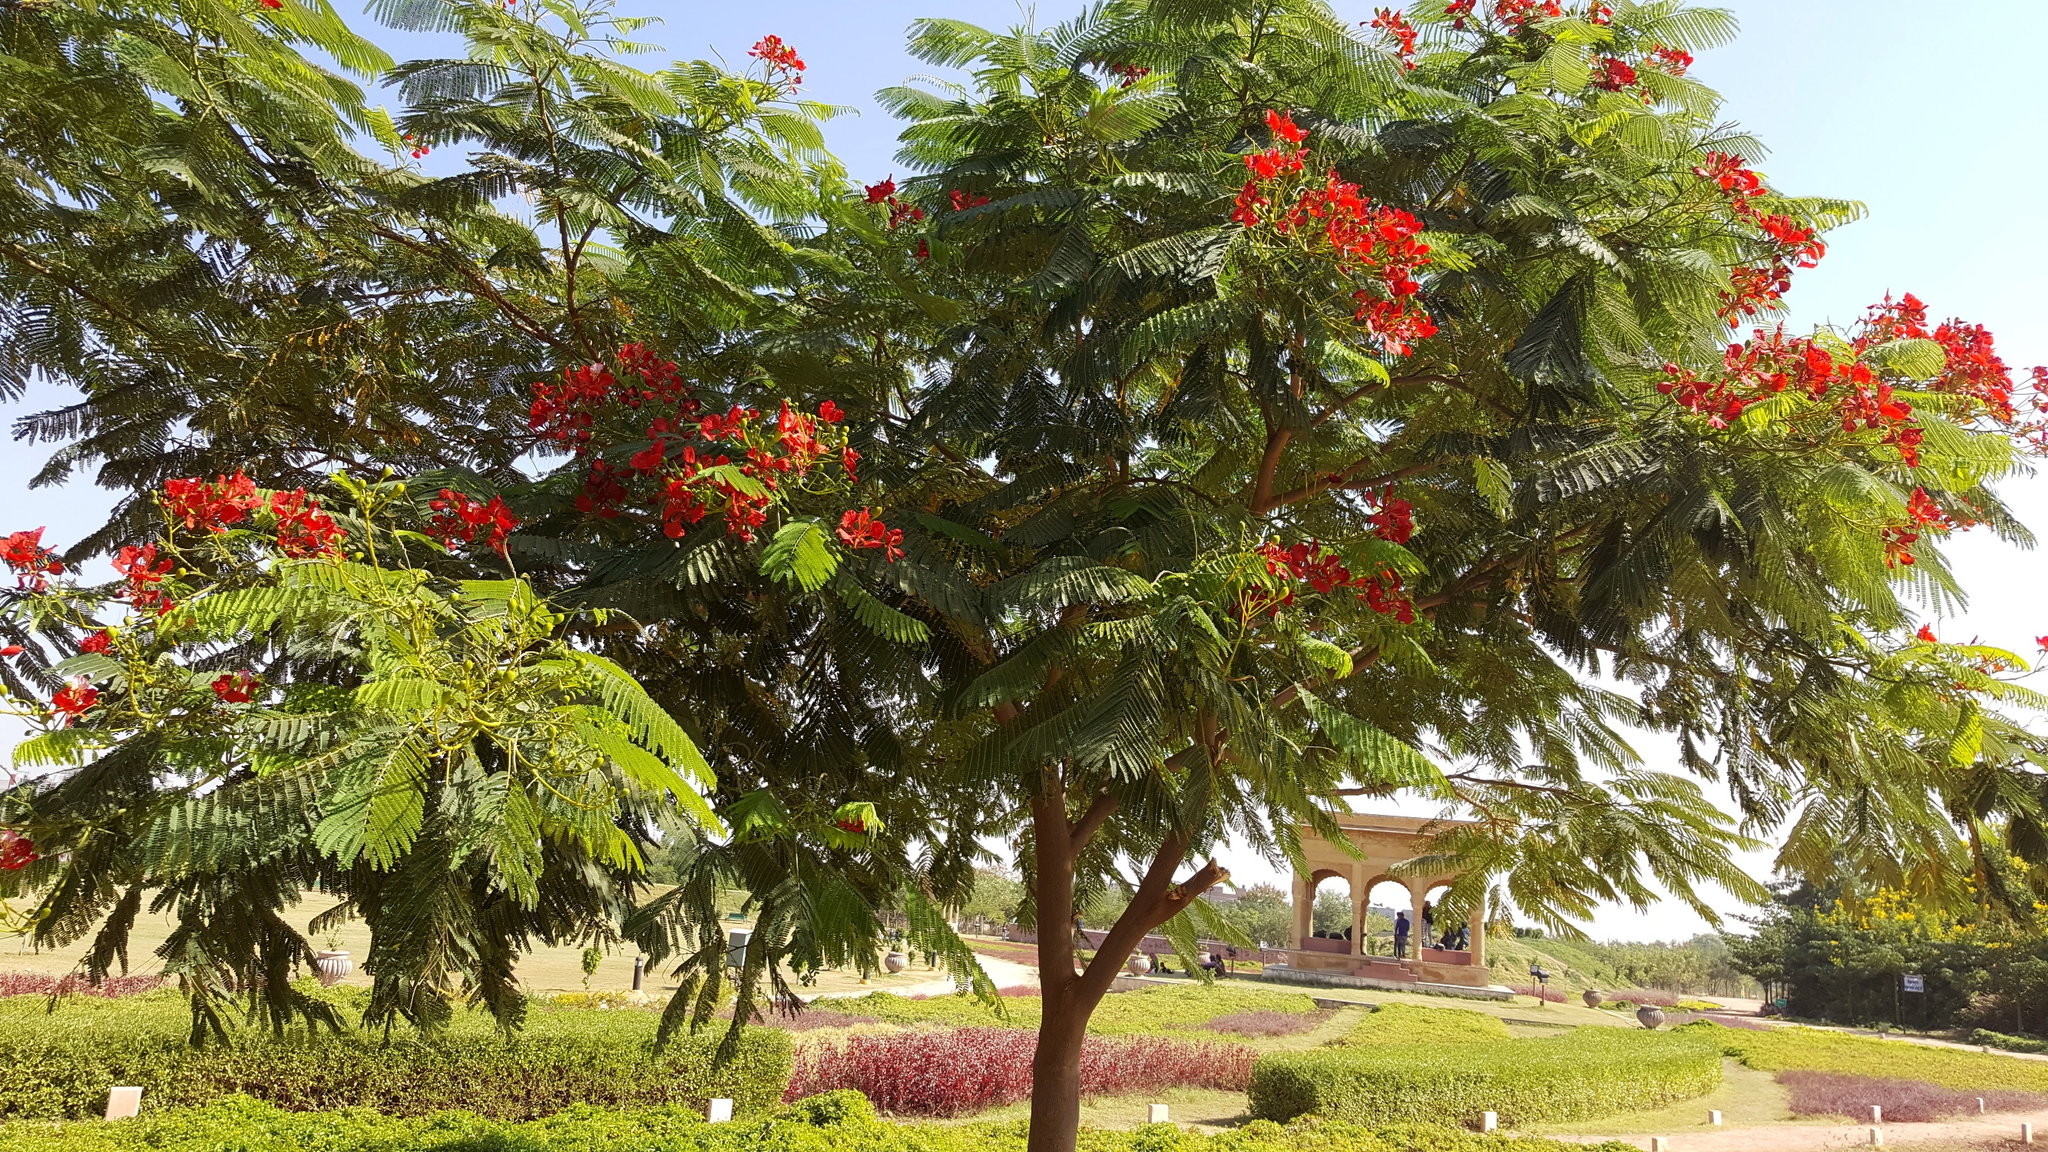How do the design and layout of the park enhance the experience for visitors? The park's design and layout appear meticulously planned to enhance the visitor's experience through a harmonious balance of natural beauty and structured design. The variety of green spaces, from neatly trimmed hedges to broader lawns, provides areas suited for different activities, such as picnicking or sports. The paths are strategically placed to allow for leisurely strolls, perhaps to optimize viewing angles of the landscape features like the vibrant tree and the classical gazebo. Overall, the environment is shaped to offer both aesthetic pleasure and functional spaces conducive to relaxation and recreation. 